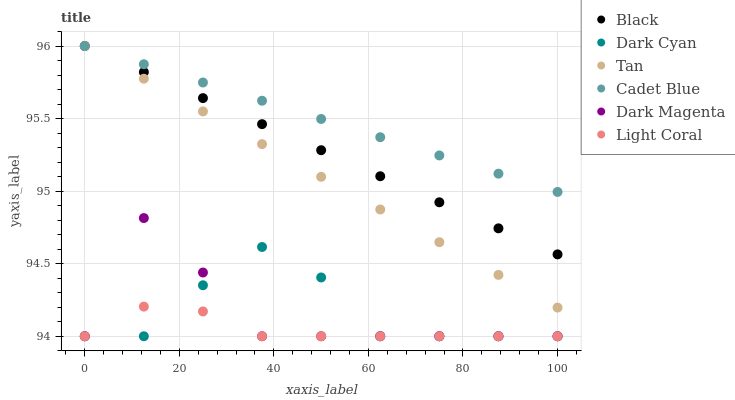Does Light Coral have the minimum area under the curve?
Answer yes or no. Yes. Does Cadet Blue have the maximum area under the curve?
Answer yes or no. Yes. Does Dark Magenta have the minimum area under the curve?
Answer yes or no. No. Does Dark Magenta have the maximum area under the curve?
Answer yes or no. No. Is Black the smoothest?
Answer yes or no. Yes. Is Dark Magenta the roughest?
Answer yes or no. Yes. Is Light Coral the smoothest?
Answer yes or no. No. Is Light Coral the roughest?
Answer yes or no. No. Does Dark Magenta have the lowest value?
Answer yes or no. Yes. Does Black have the lowest value?
Answer yes or no. No. Does Tan have the highest value?
Answer yes or no. Yes. Does Dark Magenta have the highest value?
Answer yes or no. No. Is Dark Magenta less than Black?
Answer yes or no. Yes. Is Tan greater than Light Coral?
Answer yes or no. Yes. Does Light Coral intersect Dark Cyan?
Answer yes or no. Yes. Is Light Coral less than Dark Cyan?
Answer yes or no. No. Is Light Coral greater than Dark Cyan?
Answer yes or no. No. Does Dark Magenta intersect Black?
Answer yes or no. No. 